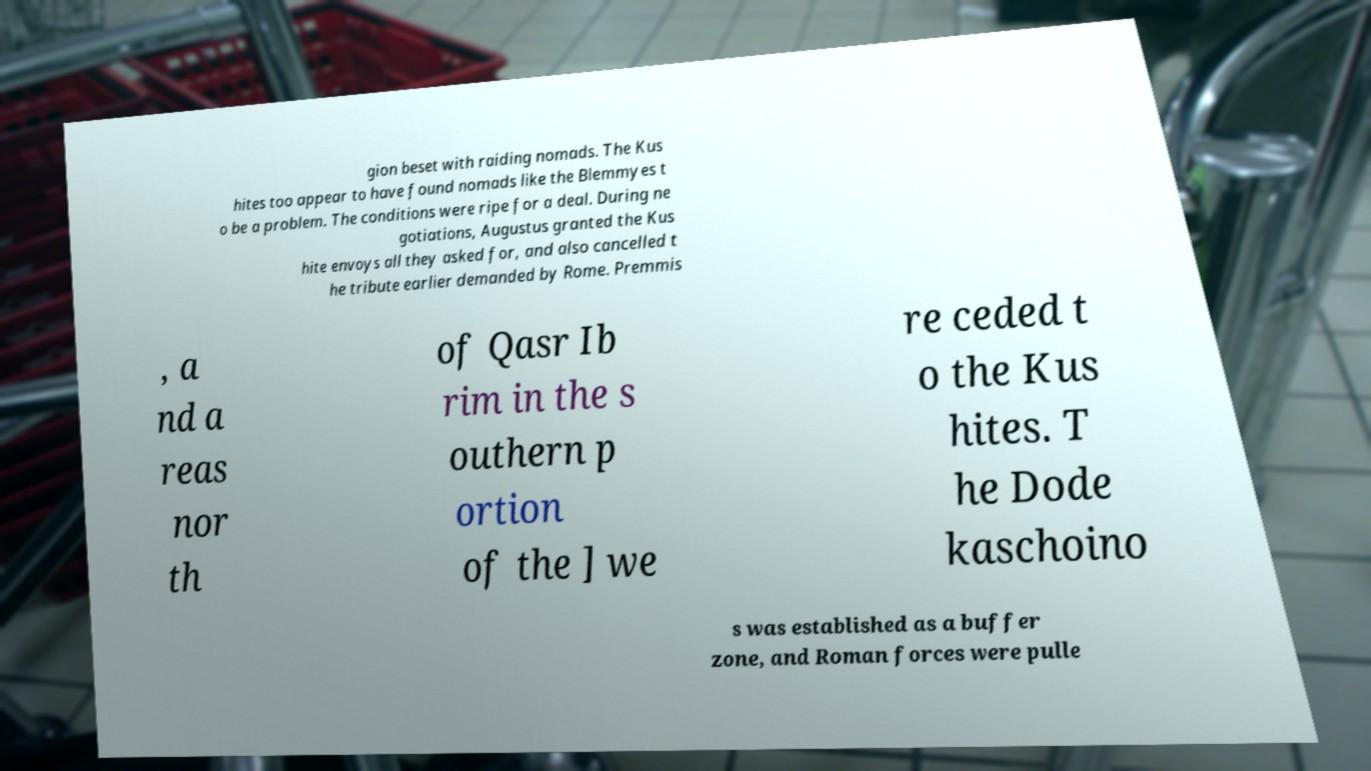For documentation purposes, I need the text within this image transcribed. Could you provide that? gion beset with raiding nomads. The Kus hites too appear to have found nomads like the Blemmyes t o be a problem. The conditions were ripe for a deal. During ne gotiations, Augustus granted the Kus hite envoys all they asked for, and also cancelled t he tribute earlier demanded by Rome. Premmis , a nd a reas nor th of Qasr Ib rim in the s outhern p ortion of the ] we re ceded t o the Kus hites. T he Dode kaschoino s was established as a buffer zone, and Roman forces were pulle 